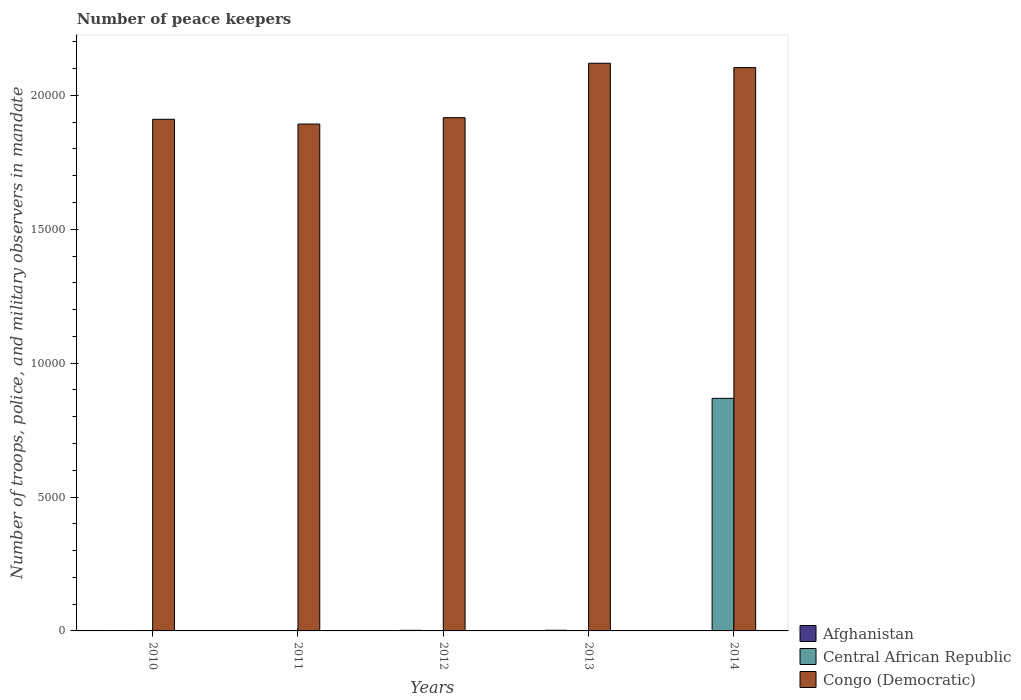How many different coloured bars are there?
Offer a terse response. 3. How many groups of bars are there?
Offer a very short reply. 5. Are the number of bars per tick equal to the number of legend labels?
Offer a very short reply. Yes. How many bars are there on the 4th tick from the left?
Keep it short and to the point. 3. How many bars are there on the 1st tick from the right?
Your answer should be compact. 3. What is the number of peace keepers in in Congo (Democratic) in 2013?
Ensure brevity in your answer.  2.12e+04. Across all years, what is the maximum number of peace keepers in in Central African Republic?
Keep it short and to the point. 8685. Across all years, what is the minimum number of peace keepers in in Afghanistan?
Your answer should be very brief. 15. In which year was the number of peace keepers in in Central African Republic minimum?
Ensure brevity in your answer.  2010. What is the total number of peace keepers in in Congo (Democratic) in the graph?
Your answer should be compact. 9.94e+04. What is the difference between the number of peace keepers in in Afghanistan in 2011 and that in 2014?
Offer a very short reply. 0. What is the difference between the number of peace keepers in in Congo (Democratic) in 2010 and the number of peace keepers in in Central African Republic in 2012?
Your answer should be very brief. 1.91e+04. What is the average number of peace keepers in in Congo (Democratic) per year?
Give a very brief answer. 1.99e+04. In the year 2011, what is the difference between the number of peace keepers in in Afghanistan and number of peace keepers in in Central African Republic?
Offer a very short reply. 11. In how many years, is the number of peace keepers in in Afghanistan greater than 11000?
Give a very brief answer. 0. What is the ratio of the number of peace keepers in in Afghanistan in 2010 to that in 2012?
Make the answer very short. 0.7. Is the number of peace keepers in in Congo (Democratic) in 2013 less than that in 2014?
Your response must be concise. No. Is the difference between the number of peace keepers in in Afghanistan in 2010 and 2013 greater than the difference between the number of peace keepers in in Central African Republic in 2010 and 2013?
Provide a short and direct response. No. What is the difference between the highest and the second highest number of peace keepers in in Congo (Democratic)?
Give a very brief answer. 162. What is the difference between the highest and the lowest number of peace keepers in in Central African Republic?
Give a very brief answer. 8682. In how many years, is the number of peace keepers in in Congo (Democratic) greater than the average number of peace keepers in in Congo (Democratic) taken over all years?
Ensure brevity in your answer.  2. What does the 3rd bar from the left in 2012 represents?
Keep it short and to the point. Congo (Democratic). What does the 2nd bar from the right in 2010 represents?
Give a very brief answer. Central African Republic. Is it the case that in every year, the sum of the number of peace keepers in in Afghanistan and number of peace keepers in in Central African Republic is greater than the number of peace keepers in in Congo (Democratic)?
Offer a very short reply. No. How many bars are there?
Ensure brevity in your answer.  15. Are all the bars in the graph horizontal?
Provide a succinct answer. No. How many years are there in the graph?
Offer a terse response. 5. Does the graph contain grids?
Offer a terse response. No. How are the legend labels stacked?
Provide a succinct answer. Vertical. What is the title of the graph?
Give a very brief answer. Number of peace keepers. Does "Iraq" appear as one of the legend labels in the graph?
Your answer should be very brief. No. What is the label or title of the Y-axis?
Offer a terse response. Number of troops, police, and military observers in mandate. What is the Number of troops, police, and military observers in mandate in Afghanistan in 2010?
Your answer should be very brief. 16. What is the Number of troops, police, and military observers in mandate in Congo (Democratic) in 2010?
Ensure brevity in your answer.  1.91e+04. What is the Number of troops, police, and military observers in mandate of Central African Republic in 2011?
Your answer should be compact. 4. What is the Number of troops, police, and military observers in mandate in Congo (Democratic) in 2011?
Your answer should be very brief. 1.89e+04. What is the Number of troops, police, and military observers in mandate in Afghanistan in 2012?
Provide a short and direct response. 23. What is the Number of troops, police, and military observers in mandate in Congo (Democratic) in 2012?
Offer a very short reply. 1.92e+04. What is the Number of troops, police, and military observers in mandate of Congo (Democratic) in 2013?
Offer a very short reply. 2.12e+04. What is the Number of troops, police, and military observers in mandate of Afghanistan in 2014?
Keep it short and to the point. 15. What is the Number of troops, police, and military observers in mandate of Central African Republic in 2014?
Provide a succinct answer. 8685. What is the Number of troops, police, and military observers in mandate in Congo (Democratic) in 2014?
Your response must be concise. 2.10e+04. Across all years, what is the maximum Number of troops, police, and military observers in mandate of Afghanistan?
Keep it short and to the point. 25. Across all years, what is the maximum Number of troops, police, and military observers in mandate of Central African Republic?
Keep it short and to the point. 8685. Across all years, what is the maximum Number of troops, police, and military observers in mandate in Congo (Democratic)?
Your answer should be very brief. 2.12e+04. Across all years, what is the minimum Number of troops, police, and military observers in mandate in Afghanistan?
Your response must be concise. 15. Across all years, what is the minimum Number of troops, police, and military observers in mandate of Central African Republic?
Provide a succinct answer. 3. Across all years, what is the minimum Number of troops, police, and military observers in mandate in Congo (Democratic)?
Your answer should be compact. 1.89e+04. What is the total Number of troops, police, and military observers in mandate in Afghanistan in the graph?
Ensure brevity in your answer.  94. What is the total Number of troops, police, and military observers in mandate of Central African Republic in the graph?
Make the answer very short. 8700. What is the total Number of troops, police, and military observers in mandate of Congo (Democratic) in the graph?
Give a very brief answer. 9.94e+04. What is the difference between the Number of troops, police, and military observers in mandate in Congo (Democratic) in 2010 and that in 2011?
Provide a short and direct response. 177. What is the difference between the Number of troops, police, and military observers in mandate of Afghanistan in 2010 and that in 2012?
Keep it short and to the point. -7. What is the difference between the Number of troops, police, and military observers in mandate in Central African Republic in 2010 and that in 2012?
Provide a short and direct response. -1. What is the difference between the Number of troops, police, and military observers in mandate in Congo (Democratic) in 2010 and that in 2012?
Offer a terse response. -61. What is the difference between the Number of troops, police, and military observers in mandate in Afghanistan in 2010 and that in 2013?
Ensure brevity in your answer.  -9. What is the difference between the Number of troops, police, and military observers in mandate of Central African Republic in 2010 and that in 2013?
Make the answer very short. -1. What is the difference between the Number of troops, police, and military observers in mandate in Congo (Democratic) in 2010 and that in 2013?
Make the answer very short. -2093. What is the difference between the Number of troops, police, and military observers in mandate in Central African Republic in 2010 and that in 2014?
Give a very brief answer. -8682. What is the difference between the Number of troops, police, and military observers in mandate of Congo (Democratic) in 2010 and that in 2014?
Give a very brief answer. -1931. What is the difference between the Number of troops, police, and military observers in mandate of Afghanistan in 2011 and that in 2012?
Provide a short and direct response. -8. What is the difference between the Number of troops, police, and military observers in mandate of Congo (Democratic) in 2011 and that in 2012?
Your answer should be very brief. -238. What is the difference between the Number of troops, police, and military observers in mandate of Central African Republic in 2011 and that in 2013?
Your answer should be compact. 0. What is the difference between the Number of troops, police, and military observers in mandate of Congo (Democratic) in 2011 and that in 2013?
Give a very brief answer. -2270. What is the difference between the Number of troops, police, and military observers in mandate in Central African Republic in 2011 and that in 2014?
Make the answer very short. -8681. What is the difference between the Number of troops, police, and military observers in mandate of Congo (Democratic) in 2011 and that in 2014?
Your answer should be very brief. -2108. What is the difference between the Number of troops, police, and military observers in mandate in Afghanistan in 2012 and that in 2013?
Your response must be concise. -2. What is the difference between the Number of troops, police, and military observers in mandate of Congo (Democratic) in 2012 and that in 2013?
Your answer should be very brief. -2032. What is the difference between the Number of troops, police, and military observers in mandate in Central African Republic in 2012 and that in 2014?
Provide a succinct answer. -8681. What is the difference between the Number of troops, police, and military observers in mandate in Congo (Democratic) in 2012 and that in 2014?
Ensure brevity in your answer.  -1870. What is the difference between the Number of troops, police, and military observers in mandate of Afghanistan in 2013 and that in 2014?
Ensure brevity in your answer.  10. What is the difference between the Number of troops, police, and military observers in mandate in Central African Republic in 2013 and that in 2014?
Keep it short and to the point. -8681. What is the difference between the Number of troops, police, and military observers in mandate of Congo (Democratic) in 2013 and that in 2014?
Keep it short and to the point. 162. What is the difference between the Number of troops, police, and military observers in mandate of Afghanistan in 2010 and the Number of troops, police, and military observers in mandate of Congo (Democratic) in 2011?
Your response must be concise. -1.89e+04. What is the difference between the Number of troops, police, and military observers in mandate in Central African Republic in 2010 and the Number of troops, police, and military observers in mandate in Congo (Democratic) in 2011?
Your answer should be very brief. -1.89e+04. What is the difference between the Number of troops, police, and military observers in mandate in Afghanistan in 2010 and the Number of troops, police, and military observers in mandate in Central African Republic in 2012?
Make the answer very short. 12. What is the difference between the Number of troops, police, and military observers in mandate in Afghanistan in 2010 and the Number of troops, police, and military observers in mandate in Congo (Democratic) in 2012?
Make the answer very short. -1.92e+04. What is the difference between the Number of troops, police, and military observers in mandate in Central African Republic in 2010 and the Number of troops, police, and military observers in mandate in Congo (Democratic) in 2012?
Give a very brief answer. -1.92e+04. What is the difference between the Number of troops, police, and military observers in mandate in Afghanistan in 2010 and the Number of troops, police, and military observers in mandate in Central African Republic in 2013?
Give a very brief answer. 12. What is the difference between the Number of troops, police, and military observers in mandate in Afghanistan in 2010 and the Number of troops, police, and military observers in mandate in Congo (Democratic) in 2013?
Offer a very short reply. -2.12e+04. What is the difference between the Number of troops, police, and military observers in mandate in Central African Republic in 2010 and the Number of troops, police, and military observers in mandate in Congo (Democratic) in 2013?
Provide a short and direct response. -2.12e+04. What is the difference between the Number of troops, police, and military observers in mandate of Afghanistan in 2010 and the Number of troops, police, and military observers in mandate of Central African Republic in 2014?
Your answer should be very brief. -8669. What is the difference between the Number of troops, police, and military observers in mandate in Afghanistan in 2010 and the Number of troops, police, and military observers in mandate in Congo (Democratic) in 2014?
Your answer should be very brief. -2.10e+04. What is the difference between the Number of troops, police, and military observers in mandate of Central African Republic in 2010 and the Number of troops, police, and military observers in mandate of Congo (Democratic) in 2014?
Offer a very short reply. -2.10e+04. What is the difference between the Number of troops, police, and military observers in mandate of Afghanistan in 2011 and the Number of troops, police, and military observers in mandate of Congo (Democratic) in 2012?
Your answer should be very brief. -1.92e+04. What is the difference between the Number of troops, police, and military observers in mandate in Central African Republic in 2011 and the Number of troops, police, and military observers in mandate in Congo (Democratic) in 2012?
Ensure brevity in your answer.  -1.92e+04. What is the difference between the Number of troops, police, and military observers in mandate in Afghanistan in 2011 and the Number of troops, police, and military observers in mandate in Congo (Democratic) in 2013?
Offer a very short reply. -2.12e+04. What is the difference between the Number of troops, police, and military observers in mandate of Central African Republic in 2011 and the Number of troops, police, and military observers in mandate of Congo (Democratic) in 2013?
Keep it short and to the point. -2.12e+04. What is the difference between the Number of troops, police, and military observers in mandate in Afghanistan in 2011 and the Number of troops, police, and military observers in mandate in Central African Republic in 2014?
Your response must be concise. -8670. What is the difference between the Number of troops, police, and military observers in mandate in Afghanistan in 2011 and the Number of troops, police, and military observers in mandate in Congo (Democratic) in 2014?
Make the answer very short. -2.10e+04. What is the difference between the Number of troops, police, and military observers in mandate in Central African Republic in 2011 and the Number of troops, police, and military observers in mandate in Congo (Democratic) in 2014?
Keep it short and to the point. -2.10e+04. What is the difference between the Number of troops, police, and military observers in mandate in Afghanistan in 2012 and the Number of troops, police, and military observers in mandate in Congo (Democratic) in 2013?
Offer a terse response. -2.12e+04. What is the difference between the Number of troops, police, and military observers in mandate of Central African Republic in 2012 and the Number of troops, police, and military observers in mandate of Congo (Democratic) in 2013?
Your answer should be compact. -2.12e+04. What is the difference between the Number of troops, police, and military observers in mandate in Afghanistan in 2012 and the Number of troops, police, and military observers in mandate in Central African Republic in 2014?
Make the answer very short. -8662. What is the difference between the Number of troops, police, and military observers in mandate in Afghanistan in 2012 and the Number of troops, police, and military observers in mandate in Congo (Democratic) in 2014?
Your answer should be very brief. -2.10e+04. What is the difference between the Number of troops, police, and military observers in mandate of Central African Republic in 2012 and the Number of troops, police, and military observers in mandate of Congo (Democratic) in 2014?
Your response must be concise. -2.10e+04. What is the difference between the Number of troops, police, and military observers in mandate in Afghanistan in 2013 and the Number of troops, police, and military observers in mandate in Central African Republic in 2014?
Offer a very short reply. -8660. What is the difference between the Number of troops, police, and military observers in mandate in Afghanistan in 2013 and the Number of troops, police, and military observers in mandate in Congo (Democratic) in 2014?
Keep it short and to the point. -2.10e+04. What is the difference between the Number of troops, police, and military observers in mandate in Central African Republic in 2013 and the Number of troops, police, and military observers in mandate in Congo (Democratic) in 2014?
Ensure brevity in your answer.  -2.10e+04. What is the average Number of troops, police, and military observers in mandate of Afghanistan per year?
Your response must be concise. 18.8. What is the average Number of troops, police, and military observers in mandate in Central African Republic per year?
Offer a terse response. 1740. What is the average Number of troops, police, and military observers in mandate of Congo (Democratic) per year?
Make the answer very short. 1.99e+04. In the year 2010, what is the difference between the Number of troops, police, and military observers in mandate in Afghanistan and Number of troops, police, and military observers in mandate in Congo (Democratic)?
Offer a very short reply. -1.91e+04. In the year 2010, what is the difference between the Number of troops, police, and military observers in mandate of Central African Republic and Number of troops, police, and military observers in mandate of Congo (Democratic)?
Your response must be concise. -1.91e+04. In the year 2011, what is the difference between the Number of troops, police, and military observers in mandate of Afghanistan and Number of troops, police, and military observers in mandate of Congo (Democratic)?
Make the answer very short. -1.89e+04. In the year 2011, what is the difference between the Number of troops, police, and military observers in mandate of Central African Republic and Number of troops, police, and military observers in mandate of Congo (Democratic)?
Make the answer very short. -1.89e+04. In the year 2012, what is the difference between the Number of troops, police, and military observers in mandate of Afghanistan and Number of troops, police, and military observers in mandate of Congo (Democratic)?
Give a very brief answer. -1.91e+04. In the year 2012, what is the difference between the Number of troops, police, and military observers in mandate of Central African Republic and Number of troops, police, and military observers in mandate of Congo (Democratic)?
Ensure brevity in your answer.  -1.92e+04. In the year 2013, what is the difference between the Number of troops, police, and military observers in mandate in Afghanistan and Number of troops, police, and military observers in mandate in Central African Republic?
Give a very brief answer. 21. In the year 2013, what is the difference between the Number of troops, police, and military observers in mandate of Afghanistan and Number of troops, police, and military observers in mandate of Congo (Democratic)?
Offer a very short reply. -2.12e+04. In the year 2013, what is the difference between the Number of troops, police, and military observers in mandate of Central African Republic and Number of troops, police, and military observers in mandate of Congo (Democratic)?
Provide a succinct answer. -2.12e+04. In the year 2014, what is the difference between the Number of troops, police, and military observers in mandate in Afghanistan and Number of troops, police, and military observers in mandate in Central African Republic?
Offer a terse response. -8670. In the year 2014, what is the difference between the Number of troops, police, and military observers in mandate of Afghanistan and Number of troops, police, and military observers in mandate of Congo (Democratic)?
Ensure brevity in your answer.  -2.10e+04. In the year 2014, what is the difference between the Number of troops, police, and military observers in mandate in Central African Republic and Number of troops, police, and military observers in mandate in Congo (Democratic)?
Give a very brief answer. -1.24e+04. What is the ratio of the Number of troops, police, and military observers in mandate of Afghanistan in 2010 to that in 2011?
Make the answer very short. 1.07. What is the ratio of the Number of troops, police, and military observers in mandate of Congo (Democratic) in 2010 to that in 2011?
Offer a very short reply. 1.01. What is the ratio of the Number of troops, police, and military observers in mandate in Afghanistan in 2010 to that in 2012?
Offer a very short reply. 0.7. What is the ratio of the Number of troops, police, and military observers in mandate of Afghanistan in 2010 to that in 2013?
Make the answer very short. 0.64. What is the ratio of the Number of troops, police, and military observers in mandate of Central African Republic in 2010 to that in 2013?
Keep it short and to the point. 0.75. What is the ratio of the Number of troops, police, and military observers in mandate in Congo (Democratic) in 2010 to that in 2013?
Provide a succinct answer. 0.9. What is the ratio of the Number of troops, police, and military observers in mandate of Afghanistan in 2010 to that in 2014?
Offer a very short reply. 1.07. What is the ratio of the Number of troops, police, and military observers in mandate in Congo (Democratic) in 2010 to that in 2014?
Give a very brief answer. 0.91. What is the ratio of the Number of troops, police, and military observers in mandate of Afghanistan in 2011 to that in 2012?
Make the answer very short. 0.65. What is the ratio of the Number of troops, police, and military observers in mandate in Congo (Democratic) in 2011 to that in 2012?
Keep it short and to the point. 0.99. What is the ratio of the Number of troops, police, and military observers in mandate in Afghanistan in 2011 to that in 2013?
Your answer should be very brief. 0.6. What is the ratio of the Number of troops, police, and military observers in mandate in Central African Republic in 2011 to that in 2013?
Your response must be concise. 1. What is the ratio of the Number of troops, police, and military observers in mandate of Congo (Democratic) in 2011 to that in 2013?
Your response must be concise. 0.89. What is the ratio of the Number of troops, police, and military observers in mandate in Afghanistan in 2011 to that in 2014?
Provide a succinct answer. 1. What is the ratio of the Number of troops, police, and military observers in mandate in Central African Republic in 2011 to that in 2014?
Provide a short and direct response. 0. What is the ratio of the Number of troops, police, and military observers in mandate of Congo (Democratic) in 2011 to that in 2014?
Your answer should be compact. 0.9. What is the ratio of the Number of troops, police, and military observers in mandate in Afghanistan in 2012 to that in 2013?
Give a very brief answer. 0.92. What is the ratio of the Number of troops, police, and military observers in mandate of Congo (Democratic) in 2012 to that in 2013?
Your answer should be compact. 0.9. What is the ratio of the Number of troops, police, and military observers in mandate in Afghanistan in 2012 to that in 2014?
Keep it short and to the point. 1.53. What is the ratio of the Number of troops, police, and military observers in mandate of Congo (Democratic) in 2012 to that in 2014?
Give a very brief answer. 0.91. What is the ratio of the Number of troops, police, and military observers in mandate of Congo (Democratic) in 2013 to that in 2014?
Make the answer very short. 1.01. What is the difference between the highest and the second highest Number of troops, police, and military observers in mandate in Afghanistan?
Your response must be concise. 2. What is the difference between the highest and the second highest Number of troops, police, and military observers in mandate in Central African Republic?
Provide a short and direct response. 8681. What is the difference between the highest and the second highest Number of troops, police, and military observers in mandate in Congo (Democratic)?
Your answer should be very brief. 162. What is the difference between the highest and the lowest Number of troops, police, and military observers in mandate in Afghanistan?
Ensure brevity in your answer.  10. What is the difference between the highest and the lowest Number of troops, police, and military observers in mandate of Central African Republic?
Give a very brief answer. 8682. What is the difference between the highest and the lowest Number of troops, police, and military observers in mandate of Congo (Democratic)?
Ensure brevity in your answer.  2270. 